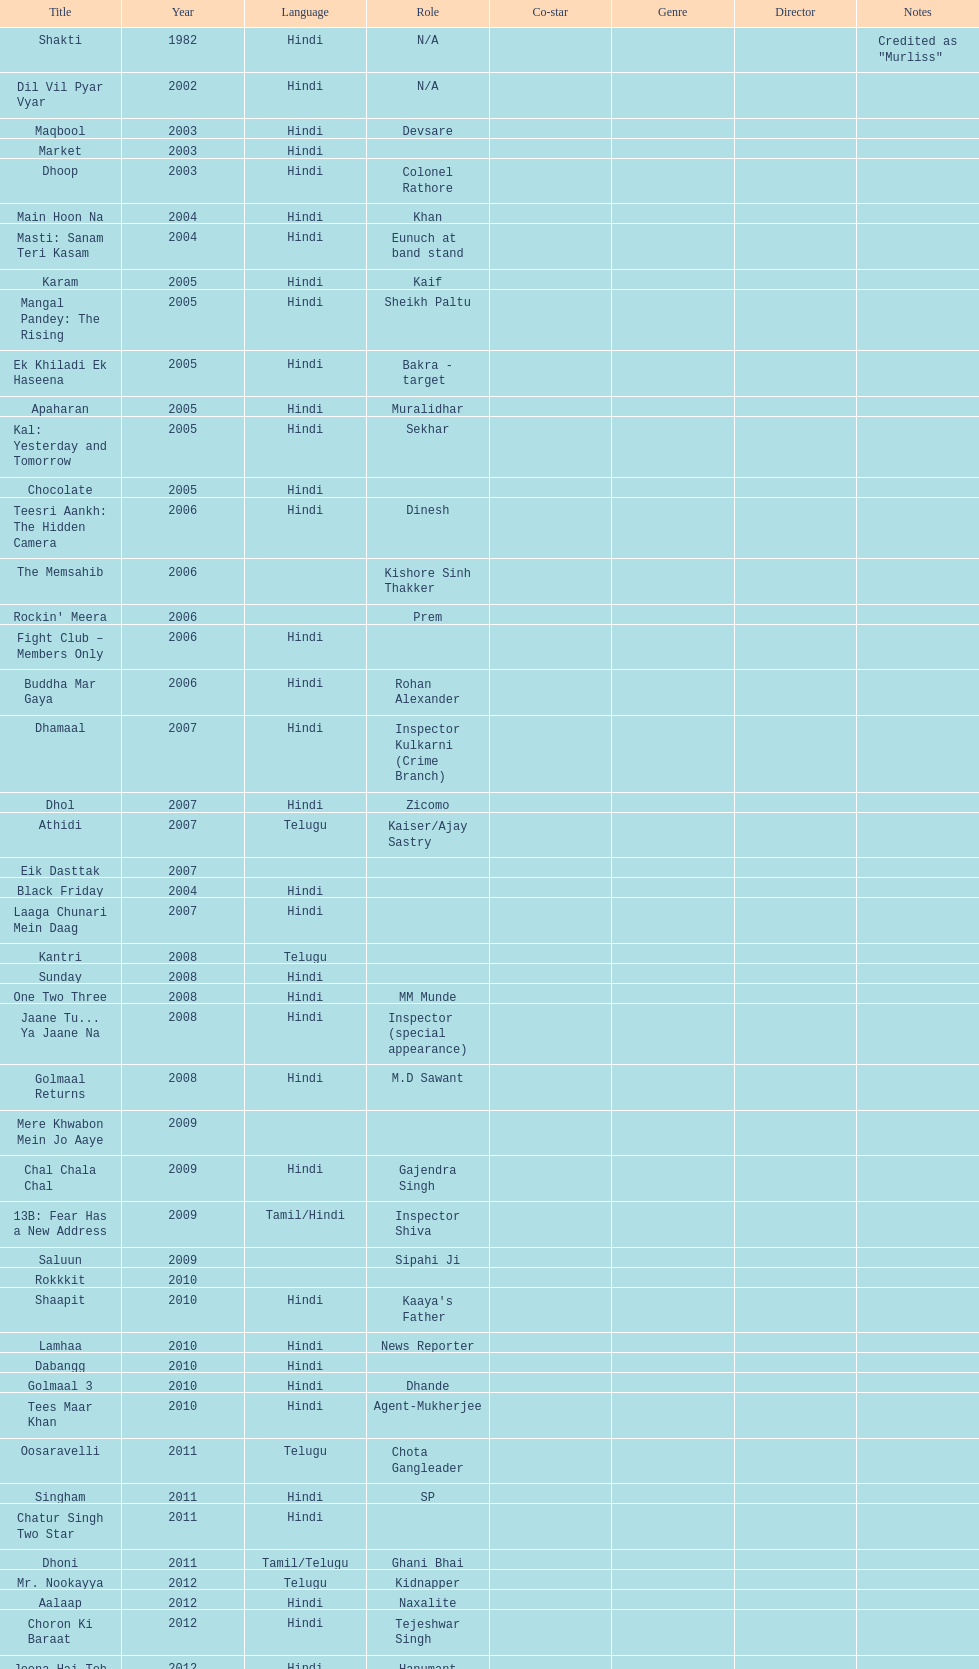How many roles has this actor had? 36. 